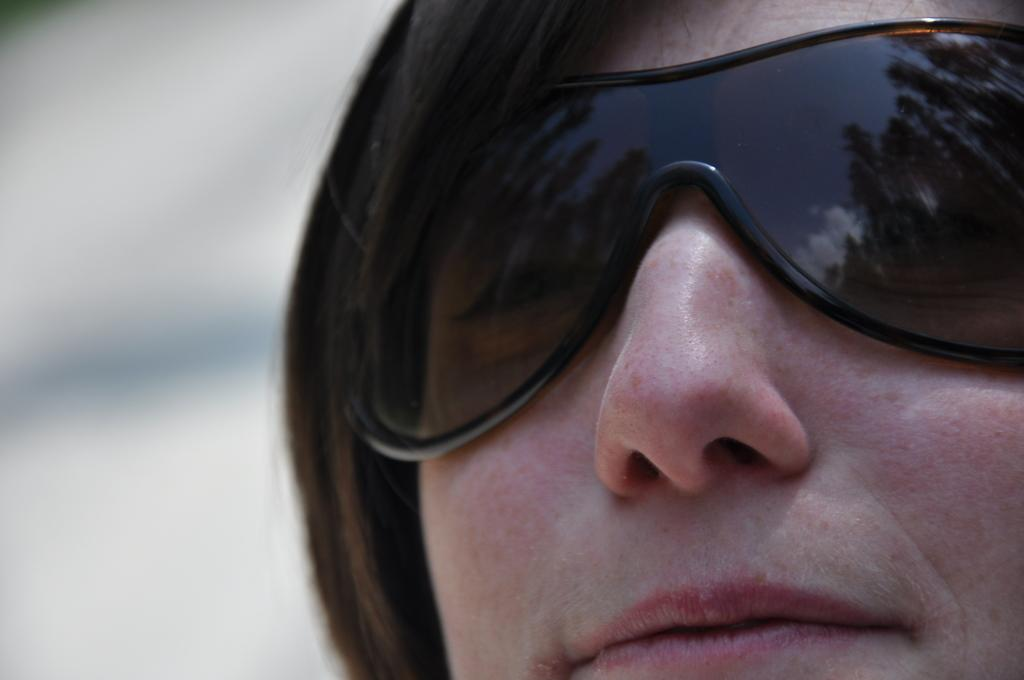Who is the main subject in the image? There is a lady in the image. What is the lady wearing on her face? The lady is wearing goggles. How many pizzas is the lady holding in the image? There is no mention of pizzas in the image, so it cannot be determined how many the lady might be holding. 